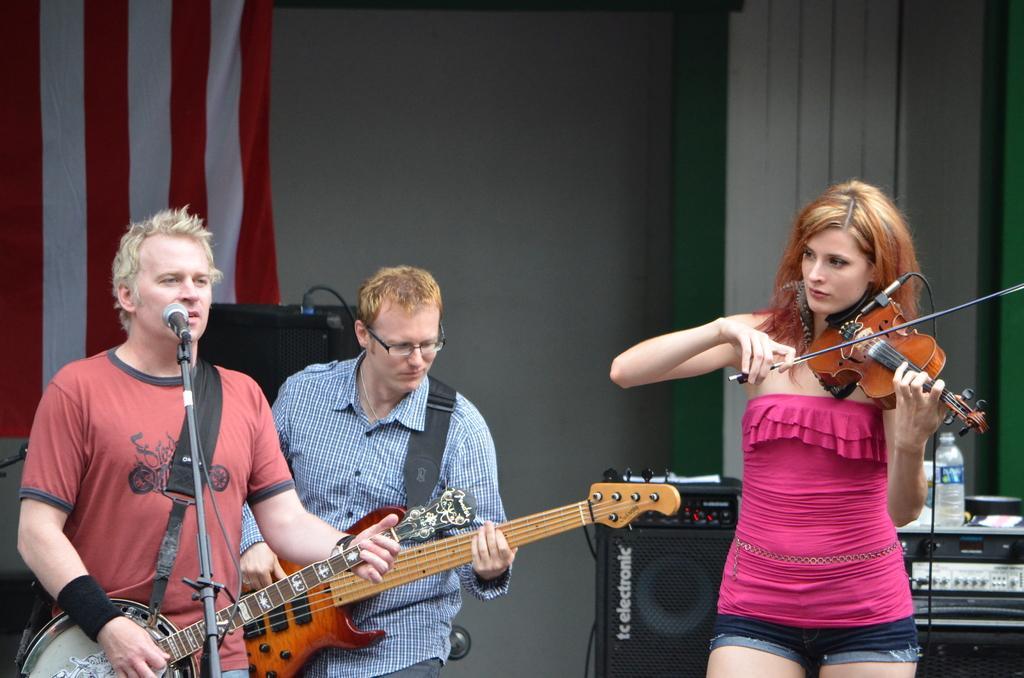Can you describe this image briefly? in this picture there are three people one woman and two men's are standing hear and playing a guitar and beside one man is standing and playing a guitar and the other person is singing in microphone and he is playing a musical instruments and back side there is a cloth which is white and red in colour and there is a sound system on that sound system there is a bottle 